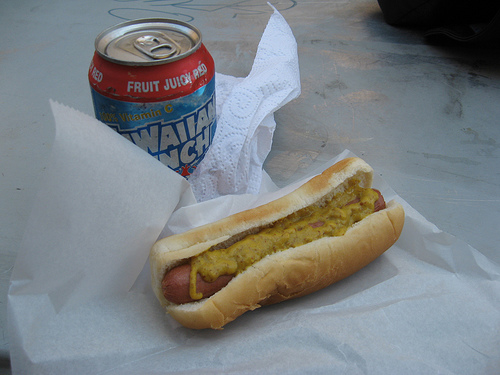<image>What state is the can from? It is unknown what state the can is from. The answers suggest it could be from New York, Hawaii, Illinois, or California. What state is the can from? It is unknown what state the can is from. 